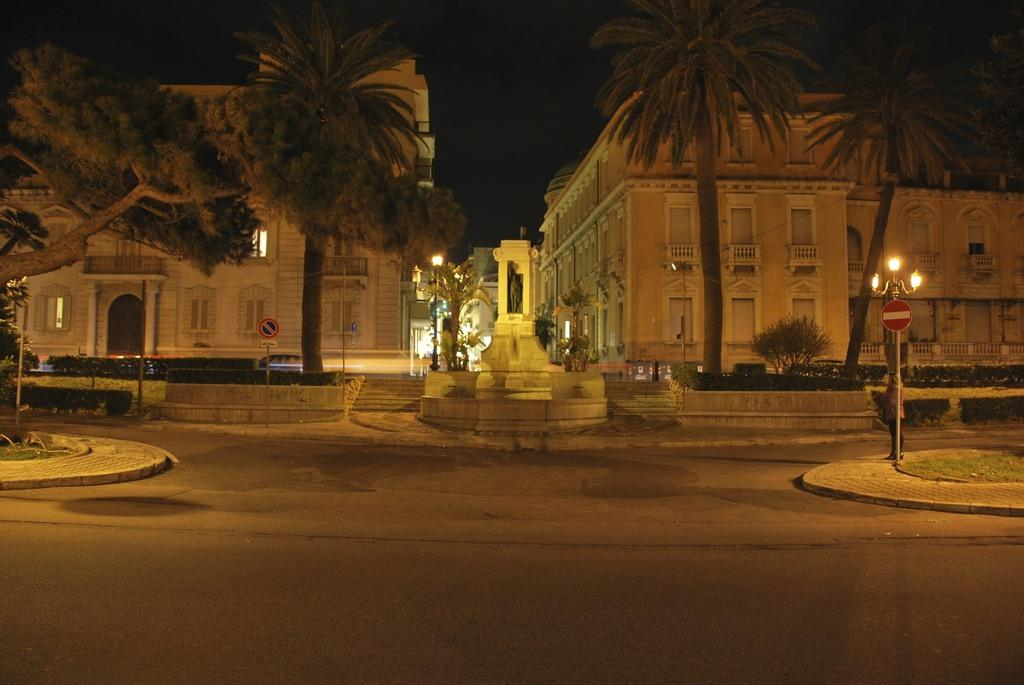What structures are present on the poles in the image? The poles have lights and boards in the image. What type of vegetation can be seen in the image? There are plants and trees in the image. What type of man-made structures are visible in the image? There are buildings in the image. How would you describe the lighting conditions in the image? The background of the image is dark. How many pickles are hanging from the trees in the image? There are no pickles present in the image; it features poles with lights and boards, plants, trees, buildings, and a dark background. 